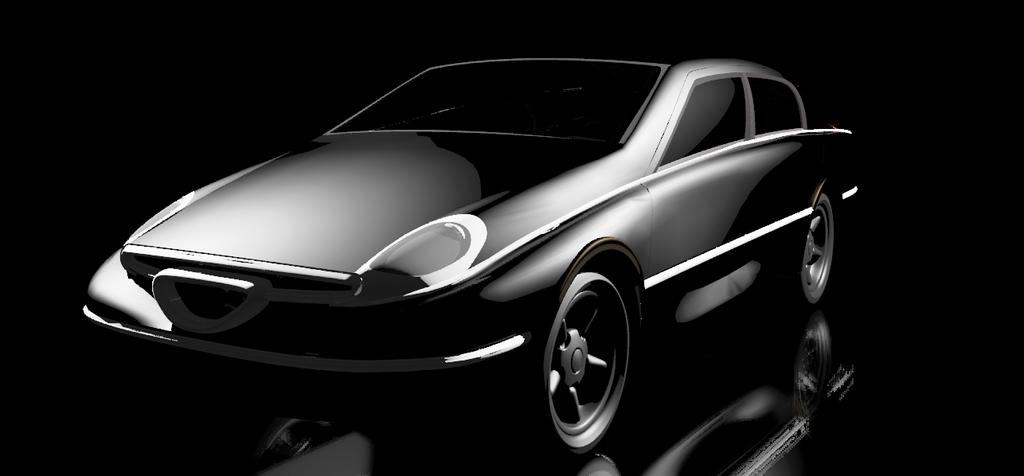What type of vehicle is in the image? There is a black car in the image. Where is the car located in the image? The car is on a platform. What color is the background of the image? The background of the image is black in color. Can you see an apple hanging from the car's rearview mirror in the image? There is no apple present in the image, nor is there any indication of one hanging from the car's rearview mirror. 